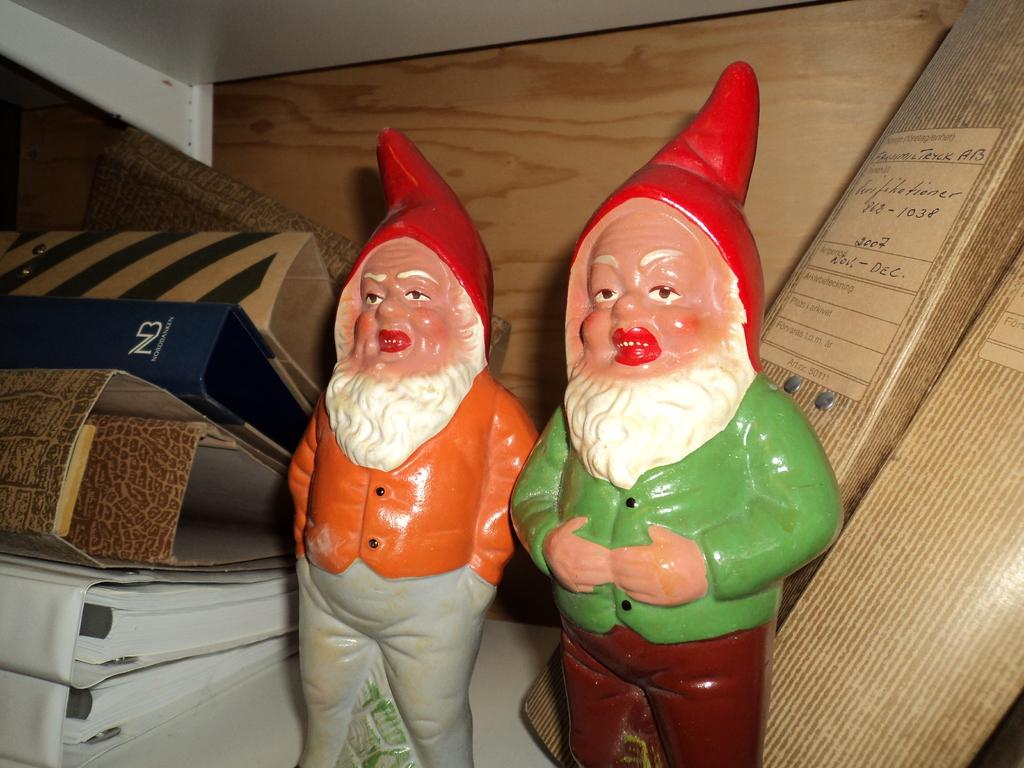How many toys are present in the image? There are two toys in the image. What else can be seen in the image besides the toys? There are files visible in the image. What is visible in the background of the image? There is a wall visible in the background of the image. What type of egg can be seen on the cushion in the image? There is no egg or cushion present in the image. What type of mountain is visible in the background of the image? There is no mountain visible in the background of the image; it features a wall. 